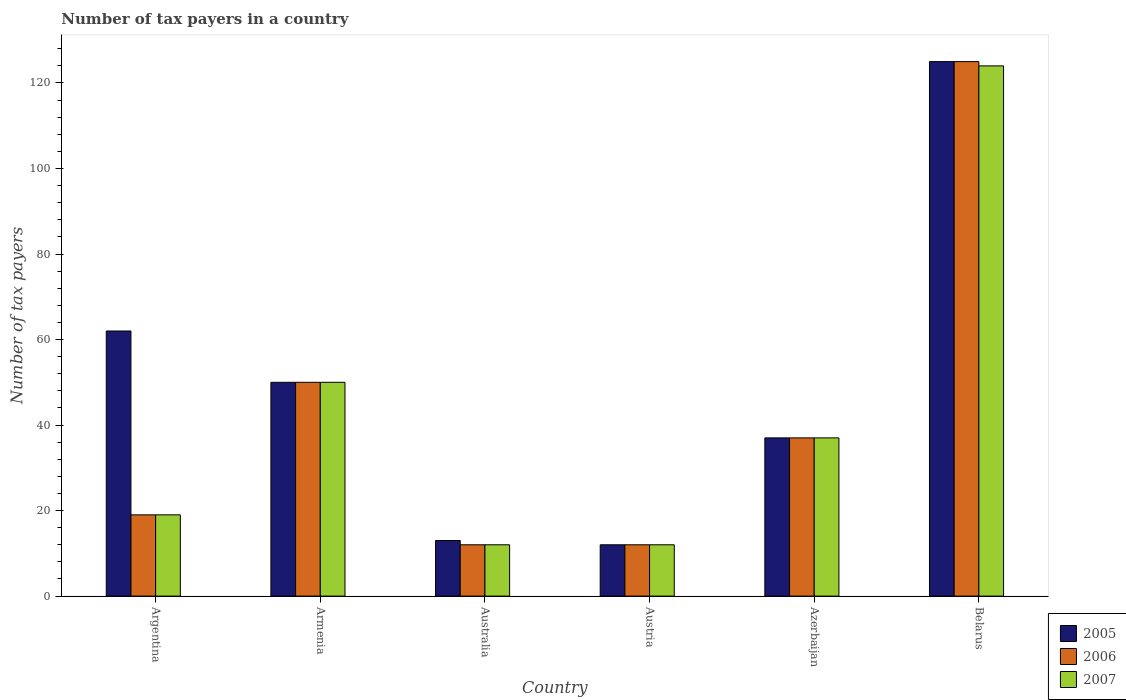Are the number of bars per tick equal to the number of legend labels?
Keep it short and to the point. Yes. How many bars are there on the 2nd tick from the left?
Ensure brevity in your answer.  3. What is the label of the 4th group of bars from the left?
Offer a terse response. Austria. What is the number of tax payers in in 2007 in Belarus?
Make the answer very short. 124. Across all countries, what is the maximum number of tax payers in in 2006?
Ensure brevity in your answer.  125. Across all countries, what is the minimum number of tax payers in in 2005?
Offer a terse response. 12. In which country was the number of tax payers in in 2005 maximum?
Provide a short and direct response. Belarus. In which country was the number of tax payers in in 2005 minimum?
Give a very brief answer. Austria. What is the total number of tax payers in in 2005 in the graph?
Provide a short and direct response. 299. What is the difference between the number of tax payers in in 2005 in Austria and that in Azerbaijan?
Keep it short and to the point. -25. What is the average number of tax payers in in 2005 per country?
Your response must be concise. 49.83. What is the difference between the number of tax payers in of/in 2005 and number of tax payers in of/in 2007 in Azerbaijan?
Make the answer very short. 0. In how many countries, is the number of tax payers in in 2006 greater than 20?
Ensure brevity in your answer.  3. What is the ratio of the number of tax payers in in 2006 in Argentina to that in Austria?
Offer a very short reply. 1.58. Is the number of tax payers in in 2007 in Armenia less than that in Belarus?
Your answer should be compact. Yes. What is the difference between the highest and the second highest number of tax payers in in 2007?
Provide a succinct answer. -74. What is the difference between the highest and the lowest number of tax payers in in 2007?
Ensure brevity in your answer.  112. In how many countries, is the number of tax payers in in 2007 greater than the average number of tax payers in in 2007 taken over all countries?
Your response must be concise. 2. What does the 2nd bar from the right in Argentina represents?
Keep it short and to the point. 2006. Is it the case that in every country, the sum of the number of tax payers in in 2007 and number of tax payers in in 2005 is greater than the number of tax payers in in 2006?
Offer a terse response. Yes. Are the values on the major ticks of Y-axis written in scientific E-notation?
Your response must be concise. No. Does the graph contain any zero values?
Your answer should be compact. No. How many legend labels are there?
Provide a short and direct response. 3. What is the title of the graph?
Your answer should be compact. Number of tax payers in a country. What is the label or title of the Y-axis?
Offer a terse response. Number of tax payers. What is the Number of tax payers of 2005 in Argentina?
Ensure brevity in your answer.  62. What is the Number of tax payers in 2006 in Argentina?
Your answer should be very brief. 19. What is the Number of tax payers in 2005 in Armenia?
Provide a succinct answer. 50. What is the Number of tax payers of 2007 in Armenia?
Provide a short and direct response. 50. What is the Number of tax payers in 2006 in Australia?
Ensure brevity in your answer.  12. What is the Number of tax payers of 2007 in Australia?
Your answer should be very brief. 12. What is the Number of tax payers in 2006 in Austria?
Give a very brief answer. 12. What is the Number of tax payers of 2007 in Austria?
Give a very brief answer. 12. What is the Number of tax payers of 2007 in Azerbaijan?
Offer a very short reply. 37. What is the Number of tax payers of 2005 in Belarus?
Provide a short and direct response. 125. What is the Number of tax payers of 2006 in Belarus?
Offer a terse response. 125. What is the Number of tax payers of 2007 in Belarus?
Your answer should be compact. 124. Across all countries, what is the maximum Number of tax payers of 2005?
Provide a succinct answer. 125. Across all countries, what is the maximum Number of tax payers in 2006?
Provide a succinct answer. 125. Across all countries, what is the maximum Number of tax payers in 2007?
Ensure brevity in your answer.  124. Across all countries, what is the minimum Number of tax payers in 2007?
Offer a very short reply. 12. What is the total Number of tax payers of 2005 in the graph?
Your answer should be compact. 299. What is the total Number of tax payers of 2006 in the graph?
Your answer should be very brief. 255. What is the total Number of tax payers of 2007 in the graph?
Offer a terse response. 254. What is the difference between the Number of tax payers of 2005 in Argentina and that in Armenia?
Keep it short and to the point. 12. What is the difference between the Number of tax payers in 2006 in Argentina and that in Armenia?
Ensure brevity in your answer.  -31. What is the difference between the Number of tax payers of 2007 in Argentina and that in Armenia?
Offer a terse response. -31. What is the difference between the Number of tax payers of 2006 in Argentina and that in Australia?
Make the answer very short. 7. What is the difference between the Number of tax payers of 2006 in Argentina and that in Austria?
Provide a short and direct response. 7. What is the difference between the Number of tax payers of 2007 in Argentina and that in Austria?
Keep it short and to the point. 7. What is the difference between the Number of tax payers in 2006 in Argentina and that in Azerbaijan?
Provide a short and direct response. -18. What is the difference between the Number of tax payers in 2005 in Argentina and that in Belarus?
Your answer should be very brief. -63. What is the difference between the Number of tax payers in 2006 in Argentina and that in Belarus?
Keep it short and to the point. -106. What is the difference between the Number of tax payers in 2007 in Argentina and that in Belarus?
Keep it short and to the point. -105. What is the difference between the Number of tax payers in 2005 in Armenia and that in Australia?
Provide a short and direct response. 37. What is the difference between the Number of tax payers of 2006 in Armenia and that in Australia?
Offer a very short reply. 38. What is the difference between the Number of tax payers in 2005 in Armenia and that in Austria?
Keep it short and to the point. 38. What is the difference between the Number of tax payers of 2007 in Armenia and that in Austria?
Offer a terse response. 38. What is the difference between the Number of tax payers in 2005 in Armenia and that in Belarus?
Offer a very short reply. -75. What is the difference between the Number of tax payers of 2006 in Armenia and that in Belarus?
Provide a short and direct response. -75. What is the difference between the Number of tax payers in 2007 in Armenia and that in Belarus?
Make the answer very short. -74. What is the difference between the Number of tax payers in 2005 in Australia and that in Austria?
Ensure brevity in your answer.  1. What is the difference between the Number of tax payers in 2007 in Australia and that in Austria?
Keep it short and to the point. 0. What is the difference between the Number of tax payers of 2005 in Australia and that in Belarus?
Your answer should be compact. -112. What is the difference between the Number of tax payers of 2006 in Australia and that in Belarus?
Offer a very short reply. -113. What is the difference between the Number of tax payers in 2007 in Australia and that in Belarus?
Offer a very short reply. -112. What is the difference between the Number of tax payers in 2006 in Austria and that in Azerbaijan?
Your response must be concise. -25. What is the difference between the Number of tax payers in 2007 in Austria and that in Azerbaijan?
Offer a very short reply. -25. What is the difference between the Number of tax payers of 2005 in Austria and that in Belarus?
Keep it short and to the point. -113. What is the difference between the Number of tax payers of 2006 in Austria and that in Belarus?
Provide a short and direct response. -113. What is the difference between the Number of tax payers of 2007 in Austria and that in Belarus?
Ensure brevity in your answer.  -112. What is the difference between the Number of tax payers in 2005 in Azerbaijan and that in Belarus?
Ensure brevity in your answer.  -88. What is the difference between the Number of tax payers in 2006 in Azerbaijan and that in Belarus?
Your response must be concise. -88. What is the difference between the Number of tax payers in 2007 in Azerbaijan and that in Belarus?
Provide a short and direct response. -87. What is the difference between the Number of tax payers of 2005 in Argentina and the Number of tax payers of 2007 in Armenia?
Make the answer very short. 12. What is the difference between the Number of tax payers in 2006 in Argentina and the Number of tax payers in 2007 in Armenia?
Provide a succinct answer. -31. What is the difference between the Number of tax payers in 2006 in Argentina and the Number of tax payers in 2007 in Australia?
Provide a short and direct response. 7. What is the difference between the Number of tax payers in 2005 in Argentina and the Number of tax payers in 2006 in Austria?
Keep it short and to the point. 50. What is the difference between the Number of tax payers in 2006 in Argentina and the Number of tax payers in 2007 in Austria?
Provide a short and direct response. 7. What is the difference between the Number of tax payers of 2005 in Argentina and the Number of tax payers of 2006 in Azerbaijan?
Offer a very short reply. 25. What is the difference between the Number of tax payers of 2006 in Argentina and the Number of tax payers of 2007 in Azerbaijan?
Offer a very short reply. -18. What is the difference between the Number of tax payers of 2005 in Argentina and the Number of tax payers of 2006 in Belarus?
Provide a short and direct response. -63. What is the difference between the Number of tax payers in 2005 in Argentina and the Number of tax payers in 2007 in Belarus?
Your answer should be compact. -62. What is the difference between the Number of tax payers in 2006 in Argentina and the Number of tax payers in 2007 in Belarus?
Ensure brevity in your answer.  -105. What is the difference between the Number of tax payers in 2006 in Armenia and the Number of tax payers in 2007 in Austria?
Your answer should be very brief. 38. What is the difference between the Number of tax payers of 2006 in Armenia and the Number of tax payers of 2007 in Azerbaijan?
Make the answer very short. 13. What is the difference between the Number of tax payers of 2005 in Armenia and the Number of tax payers of 2006 in Belarus?
Your answer should be compact. -75. What is the difference between the Number of tax payers of 2005 in Armenia and the Number of tax payers of 2007 in Belarus?
Provide a short and direct response. -74. What is the difference between the Number of tax payers of 2006 in Armenia and the Number of tax payers of 2007 in Belarus?
Your response must be concise. -74. What is the difference between the Number of tax payers in 2006 in Australia and the Number of tax payers in 2007 in Austria?
Your answer should be very brief. 0. What is the difference between the Number of tax payers of 2005 in Australia and the Number of tax payers of 2006 in Azerbaijan?
Keep it short and to the point. -24. What is the difference between the Number of tax payers of 2006 in Australia and the Number of tax payers of 2007 in Azerbaijan?
Ensure brevity in your answer.  -25. What is the difference between the Number of tax payers of 2005 in Australia and the Number of tax payers of 2006 in Belarus?
Provide a succinct answer. -112. What is the difference between the Number of tax payers in 2005 in Australia and the Number of tax payers in 2007 in Belarus?
Offer a terse response. -111. What is the difference between the Number of tax payers in 2006 in Australia and the Number of tax payers in 2007 in Belarus?
Offer a very short reply. -112. What is the difference between the Number of tax payers in 2005 in Austria and the Number of tax payers in 2006 in Azerbaijan?
Your answer should be very brief. -25. What is the difference between the Number of tax payers of 2006 in Austria and the Number of tax payers of 2007 in Azerbaijan?
Provide a short and direct response. -25. What is the difference between the Number of tax payers in 2005 in Austria and the Number of tax payers in 2006 in Belarus?
Ensure brevity in your answer.  -113. What is the difference between the Number of tax payers of 2005 in Austria and the Number of tax payers of 2007 in Belarus?
Offer a terse response. -112. What is the difference between the Number of tax payers of 2006 in Austria and the Number of tax payers of 2007 in Belarus?
Give a very brief answer. -112. What is the difference between the Number of tax payers in 2005 in Azerbaijan and the Number of tax payers in 2006 in Belarus?
Your response must be concise. -88. What is the difference between the Number of tax payers of 2005 in Azerbaijan and the Number of tax payers of 2007 in Belarus?
Your answer should be compact. -87. What is the difference between the Number of tax payers of 2006 in Azerbaijan and the Number of tax payers of 2007 in Belarus?
Offer a terse response. -87. What is the average Number of tax payers of 2005 per country?
Give a very brief answer. 49.83. What is the average Number of tax payers of 2006 per country?
Your answer should be compact. 42.5. What is the average Number of tax payers in 2007 per country?
Your answer should be compact. 42.33. What is the difference between the Number of tax payers in 2005 and Number of tax payers in 2007 in Argentina?
Offer a very short reply. 43. What is the difference between the Number of tax payers in 2005 and Number of tax payers in 2006 in Armenia?
Your answer should be compact. 0. What is the difference between the Number of tax payers in 2005 and Number of tax payers in 2007 in Armenia?
Ensure brevity in your answer.  0. What is the difference between the Number of tax payers of 2005 and Number of tax payers of 2007 in Australia?
Offer a very short reply. 1. What is the difference between the Number of tax payers in 2006 and Number of tax payers in 2007 in Australia?
Your response must be concise. 0. What is the difference between the Number of tax payers in 2006 and Number of tax payers in 2007 in Austria?
Keep it short and to the point. 0. What is the difference between the Number of tax payers of 2005 and Number of tax payers of 2006 in Azerbaijan?
Ensure brevity in your answer.  0. What is the difference between the Number of tax payers of 2006 and Number of tax payers of 2007 in Azerbaijan?
Offer a terse response. 0. What is the difference between the Number of tax payers of 2005 and Number of tax payers of 2007 in Belarus?
Offer a terse response. 1. What is the difference between the Number of tax payers in 2006 and Number of tax payers in 2007 in Belarus?
Make the answer very short. 1. What is the ratio of the Number of tax payers in 2005 in Argentina to that in Armenia?
Provide a short and direct response. 1.24. What is the ratio of the Number of tax payers of 2006 in Argentina to that in Armenia?
Provide a short and direct response. 0.38. What is the ratio of the Number of tax payers in 2007 in Argentina to that in Armenia?
Offer a very short reply. 0.38. What is the ratio of the Number of tax payers of 2005 in Argentina to that in Australia?
Give a very brief answer. 4.77. What is the ratio of the Number of tax payers of 2006 in Argentina to that in Australia?
Make the answer very short. 1.58. What is the ratio of the Number of tax payers in 2007 in Argentina to that in Australia?
Provide a short and direct response. 1.58. What is the ratio of the Number of tax payers in 2005 in Argentina to that in Austria?
Your answer should be compact. 5.17. What is the ratio of the Number of tax payers in 2006 in Argentina to that in Austria?
Provide a short and direct response. 1.58. What is the ratio of the Number of tax payers of 2007 in Argentina to that in Austria?
Ensure brevity in your answer.  1.58. What is the ratio of the Number of tax payers in 2005 in Argentina to that in Azerbaijan?
Give a very brief answer. 1.68. What is the ratio of the Number of tax payers of 2006 in Argentina to that in Azerbaijan?
Offer a terse response. 0.51. What is the ratio of the Number of tax payers of 2007 in Argentina to that in Azerbaijan?
Your answer should be very brief. 0.51. What is the ratio of the Number of tax payers of 2005 in Argentina to that in Belarus?
Your answer should be very brief. 0.5. What is the ratio of the Number of tax payers in 2006 in Argentina to that in Belarus?
Provide a short and direct response. 0.15. What is the ratio of the Number of tax payers in 2007 in Argentina to that in Belarus?
Provide a succinct answer. 0.15. What is the ratio of the Number of tax payers in 2005 in Armenia to that in Australia?
Ensure brevity in your answer.  3.85. What is the ratio of the Number of tax payers of 2006 in Armenia to that in Australia?
Provide a short and direct response. 4.17. What is the ratio of the Number of tax payers in 2007 in Armenia to that in Australia?
Make the answer very short. 4.17. What is the ratio of the Number of tax payers in 2005 in Armenia to that in Austria?
Keep it short and to the point. 4.17. What is the ratio of the Number of tax payers of 2006 in Armenia to that in Austria?
Your answer should be compact. 4.17. What is the ratio of the Number of tax payers of 2007 in Armenia to that in Austria?
Make the answer very short. 4.17. What is the ratio of the Number of tax payers in 2005 in Armenia to that in Azerbaijan?
Offer a terse response. 1.35. What is the ratio of the Number of tax payers of 2006 in Armenia to that in Azerbaijan?
Give a very brief answer. 1.35. What is the ratio of the Number of tax payers in 2007 in Armenia to that in Azerbaijan?
Ensure brevity in your answer.  1.35. What is the ratio of the Number of tax payers of 2005 in Armenia to that in Belarus?
Give a very brief answer. 0.4. What is the ratio of the Number of tax payers of 2006 in Armenia to that in Belarus?
Your answer should be compact. 0.4. What is the ratio of the Number of tax payers of 2007 in Armenia to that in Belarus?
Give a very brief answer. 0.4. What is the ratio of the Number of tax payers of 2005 in Australia to that in Austria?
Provide a succinct answer. 1.08. What is the ratio of the Number of tax payers in 2006 in Australia to that in Austria?
Provide a short and direct response. 1. What is the ratio of the Number of tax payers in 2007 in Australia to that in Austria?
Your answer should be compact. 1. What is the ratio of the Number of tax payers of 2005 in Australia to that in Azerbaijan?
Keep it short and to the point. 0.35. What is the ratio of the Number of tax payers in 2006 in Australia to that in Azerbaijan?
Offer a terse response. 0.32. What is the ratio of the Number of tax payers in 2007 in Australia to that in Azerbaijan?
Keep it short and to the point. 0.32. What is the ratio of the Number of tax payers of 2005 in Australia to that in Belarus?
Make the answer very short. 0.1. What is the ratio of the Number of tax payers of 2006 in Australia to that in Belarus?
Give a very brief answer. 0.1. What is the ratio of the Number of tax payers of 2007 in Australia to that in Belarus?
Your response must be concise. 0.1. What is the ratio of the Number of tax payers in 2005 in Austria to that in Azerbaijan?
Offer a terse response. 0.32. What is the ratio of the Number of tax payers of 2006 in Austria to that in Azerbaijan?
Your response must be concise. 0.32. What is the ratio of the Number of tax payers in 2007 in Austria to that in Azerbaijan?
Offer a very short reply. 0.32. What is the ratio of the Number of tax payers in 2005 in Austria to that in Belarus?
Ensure brevity in your answer.  0.1. What is the ratio of the Number of tax payers of 2006 in Austria to that in Belarus?
Keep it short and to the point. 0.1. What is the ratio of the Number of tax payers of 2007 in Austria to that in Belarus?
Keep it short and to the point. 0.1. What is the ratio of the Number of tax payers in 2005 in Azerbaijan to that in Belarus?
Your answer should be very brief. 0.3. What is the ratio of the Number of tax payers of 2006 in Azerbaijan to that in Belarus?
Give a very brief answer. 0.3. What is the ratio of the Number of tax payers of 2007 in Azerbaijan to that in Belarus?
Offer a terse response. 0.3. What is the difference between the highest and the second highest Number of tax payers of 2005?
Make the answer very short. 63. What is the difference between the highest and the lowest Number of tax payers of 2005?
Offer a terse response. 113. What is the difference between the highest and the lowest Number of tax payers in 2006?
Ensure brevity in your answer.  113. What is the difference between the highest and the lowest Number of tax payers of 2007?
Offer a terse response. 112. 